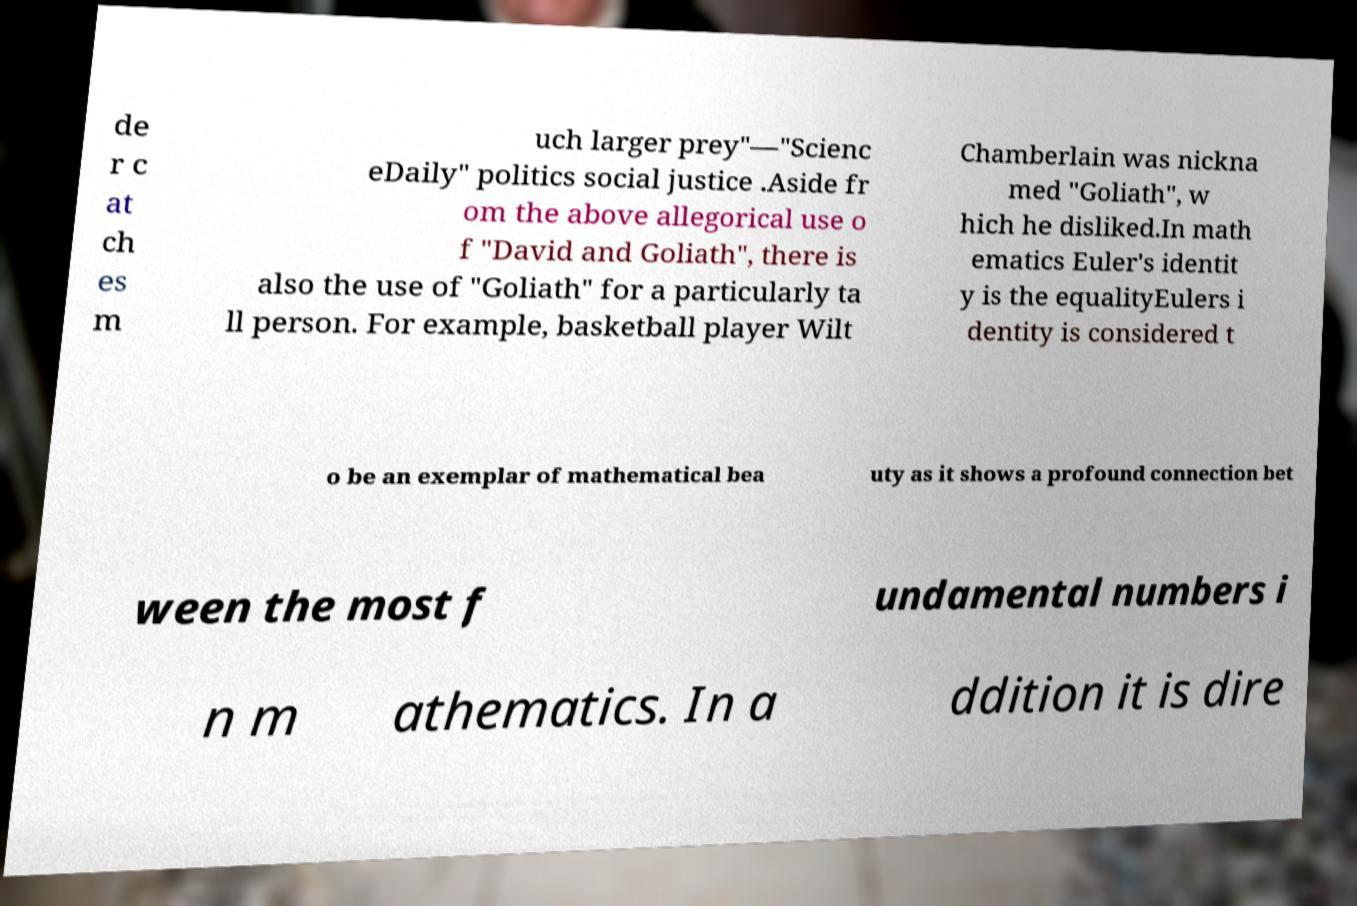I need the written content from this picture converted into text. Can you do that? de r c at ch es m uch larger prey"—"Scienc eDaily" politics social justice .Aside fr om the above allegorical use o f "David and Goliath", there is also the use of "Goliath" for a particularly ta ll person. For example, basketball player Wilt Chamberlain was nickna med "Goliath", w hich he disliked.In math ematics Euler's identit y is the equalityEulers i dentity is considered t o be an exemplar of mathematical bea uty as it shows a profound connection bet ween the most f undamental numbers i n m athematics. In a ddition it is dire 